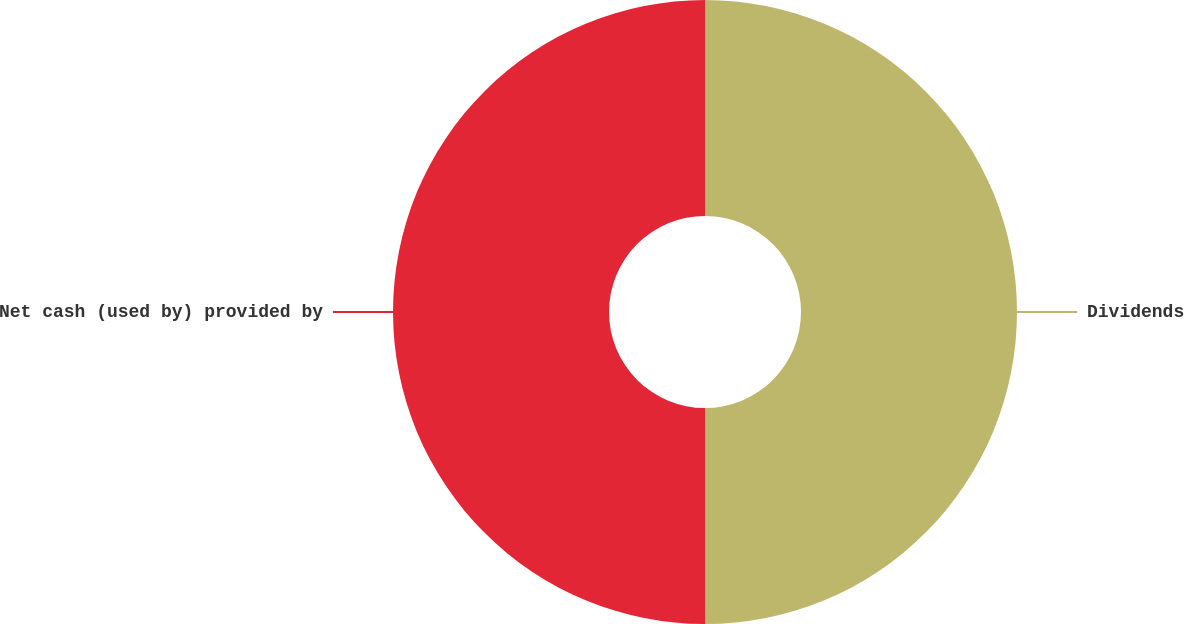Convert chart. <chart><loc_0><loc_0><loc_500><loc_500><pie_chart><fcel>Dividends<fcel>Net cash (used by) provided by<nl><fcel>50.0%<fcel>50.0%<nl></chart> 